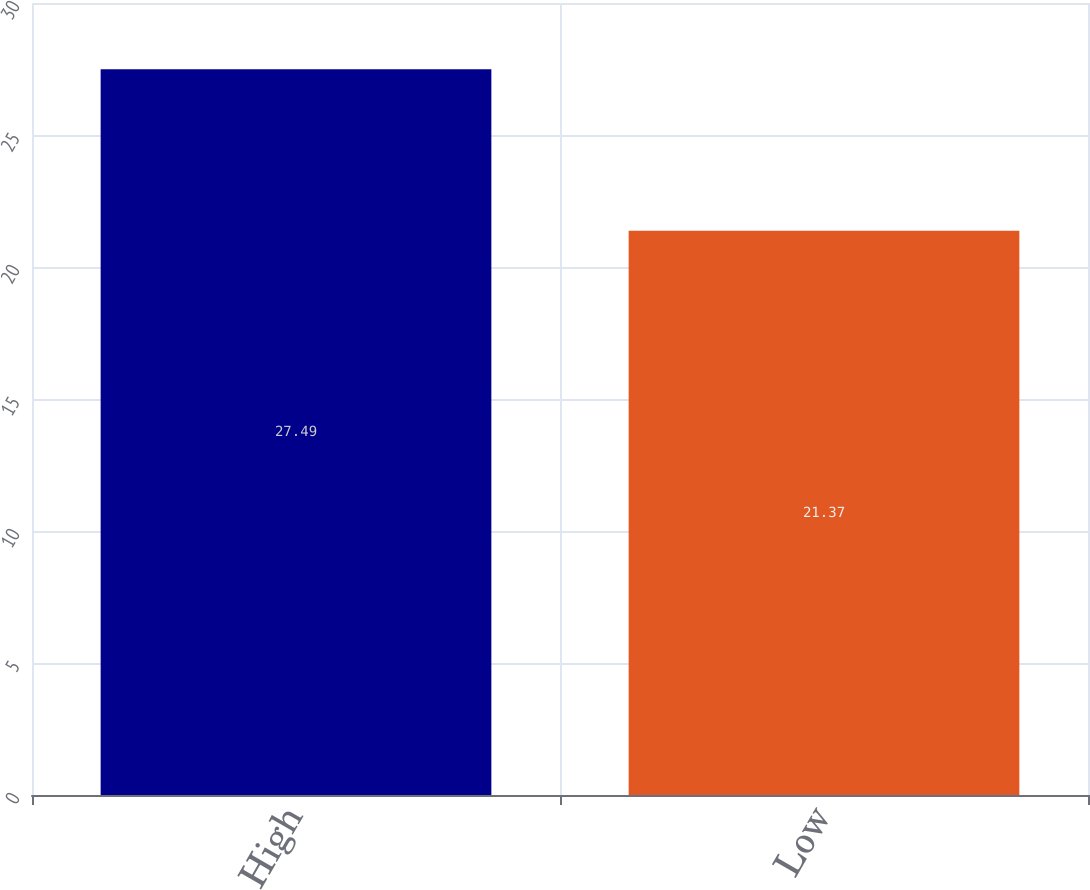Convert chart. <chart><loc_0><loc_0><loc_500><loc_500><bar_chart><fcel>High<fcel>Low<nl><fcel>27.49<fcel>21.37<nl></chart> 